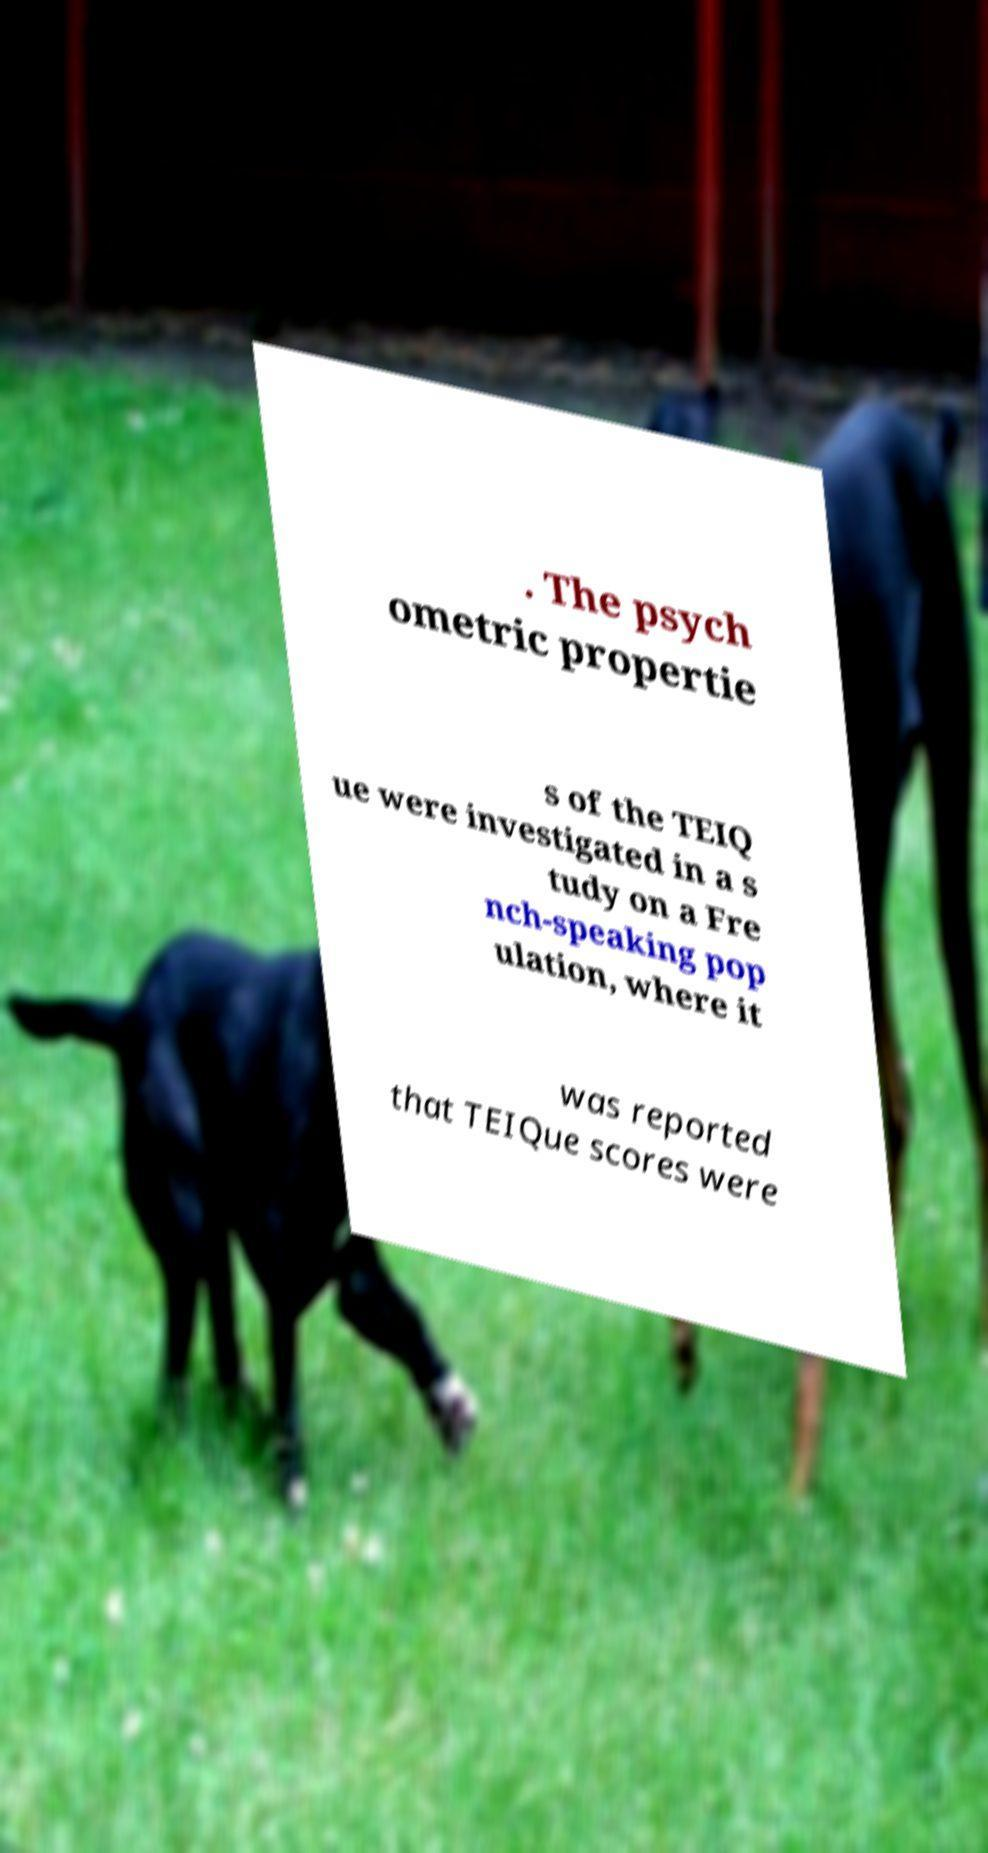Can you accurately transcribe the text from the provided image for me? . The psych ometric propertie s of the TEIQ ue were investigated in a s tudy on a Fre nch-speaking pop ulation, where it was reported that TEIQue scores were 